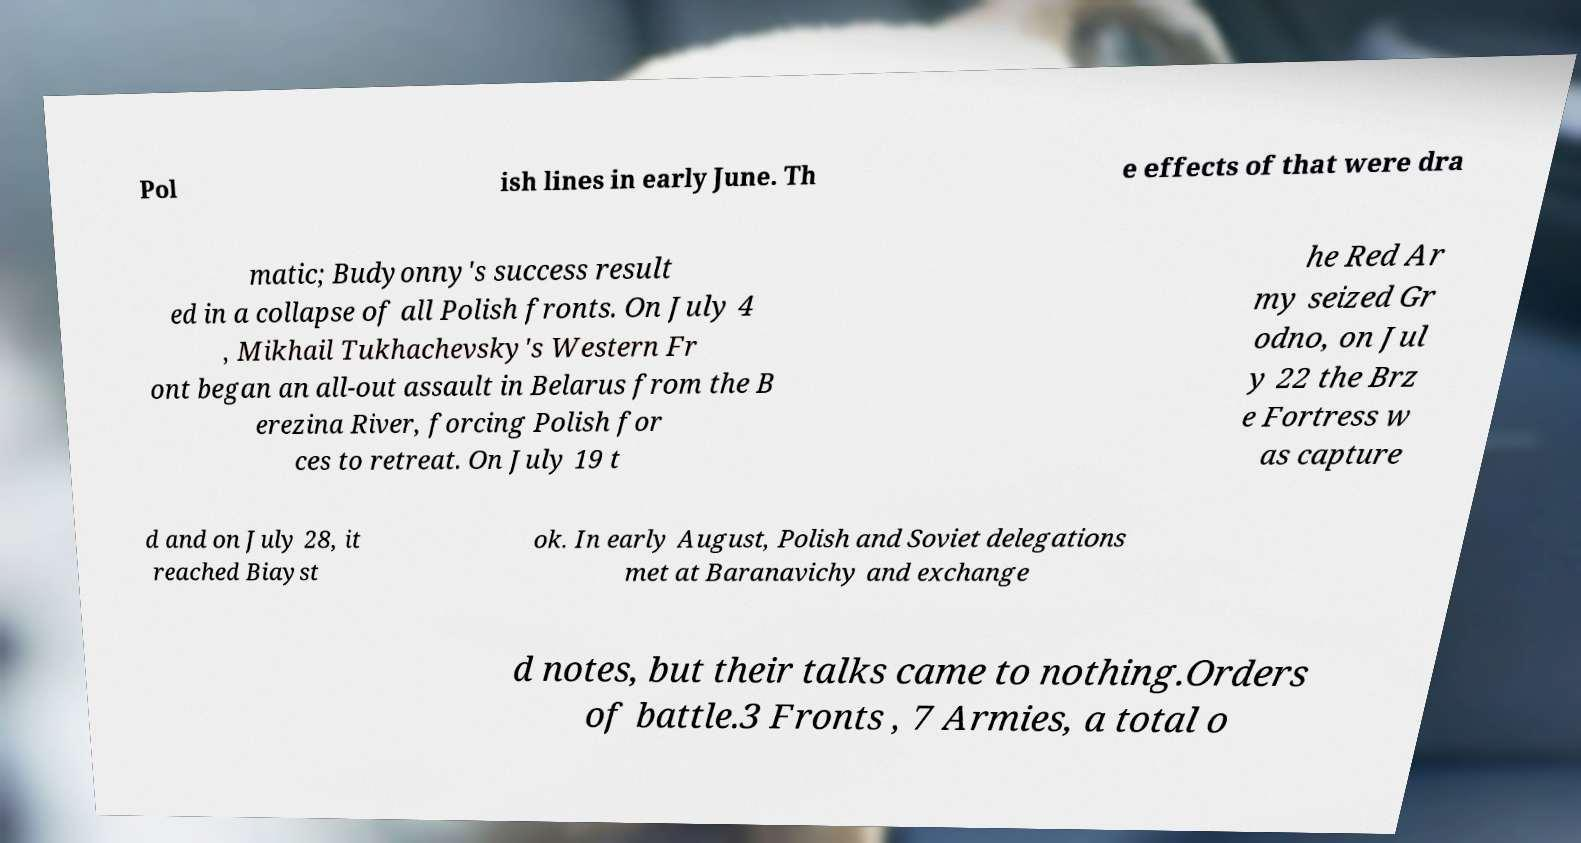Could you assist in decoding the text presented in this image and type it out clearly? Pol ish lines in early June. Th e effects of that were dra matic; Budyonny's success result ed in a collapse of all Polish fronts. On July 4 , Mikhail Tukhachevsky's Western Fr ont began an all-out assault in Belarus from the B erezina River, forcing Polish for ces to retreat. On July 19 t he Red Ar my seized Gr odno, on Jul y 22 the Brz e Fortress w as capture d and on July 28, it reached Biayst ok. In early August, Polish and Soviet delegations met at Baranavichy and exchange d notes, but their talks came to nothing.Orders of battle.3 Fronts , 7 Armies, a total o 